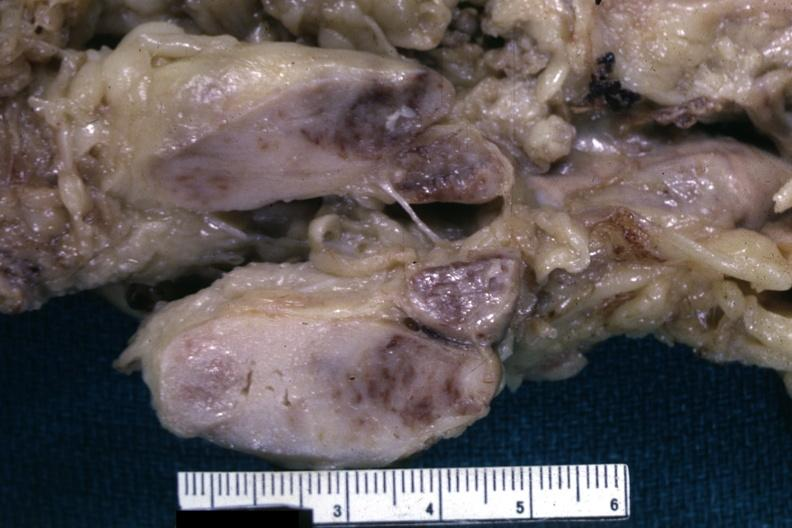s this fixed tissue cut surface of nodes shows infiltrative lesion quite well and does not show matting history of this case is unknown could have been a seminoma see other slides?
Answer the question using a single word or phrase. Yes 